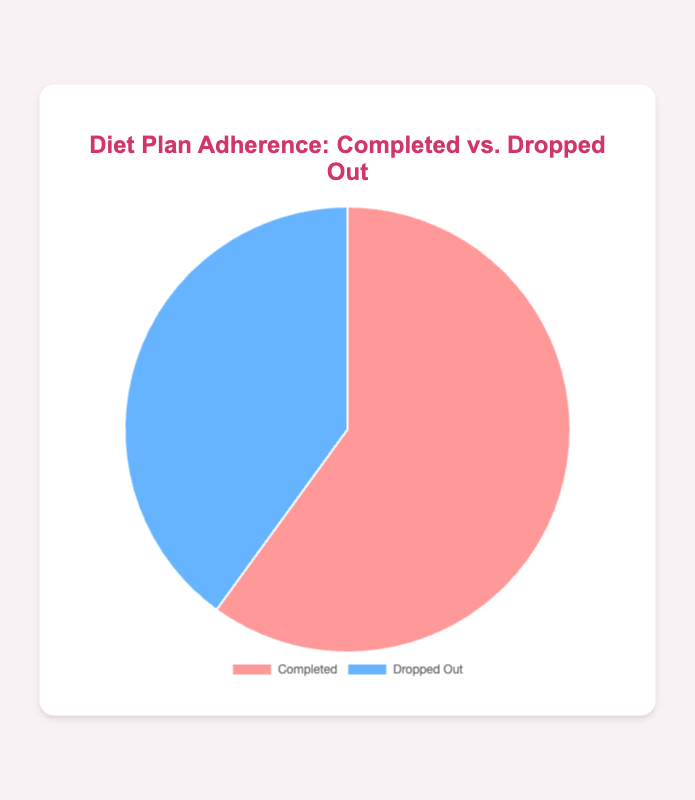Which group is larger, those who completed the diet plan or those who dropped out? The pie chart displays two segments: one indicating the number of people who completed the diet plan and one for those who dropped out. By visual inspection of the segment sizes, it's clear that the segment for people who completed is larger.
Answer: Completed What percentage of participants completed the diet plan? The pie chart shows the number of people who completed (120) and those who dropped out (80). The total number of participants is the sum of both groups: 120 + 80 = 200. The percentage of those who completed is calculated as (120/200) * 100.
Answer: 60% What is the percentage difference between those who completed the diet plan and those who dropped out? To find the percentage difference, first calculate the differences in the percentages of those who completed and dropped out. (120/200)*100 = 60% completed and (80/200)*100 = 40% dropped out. The percentage difference is 60% - 40%.
Answer: 20% Which segment is represented by a blue color in the pie chart? According to the data and the accompanying color descriptions, the blue segment represents the group that dropped out.
Answer: Dropped out If 20 more participants completed the diet plan, what would the new percentage of those who completed be? If 20 more participants completed the diet plan, the new number who completed would be 120 + 20 = 140. The total number of participants would be 140 + 80 = 220. The new percentage of those who completed would be (140/220)*100.
Answer: 63.64% How much larger is the number of people who completed the diet plan compared to those who dropped out? The number of people who completed the diet plan is 120, while the number who dropped out is 80. The difference between these two numbers is 120 - 80.
Answer: 40 What is the total number of participants in the diet plan study? The number of people who completed the diet plan is 120, and those who dropped out is 80. Adding these two numbers gives the total number of participants.
Answer: 200 